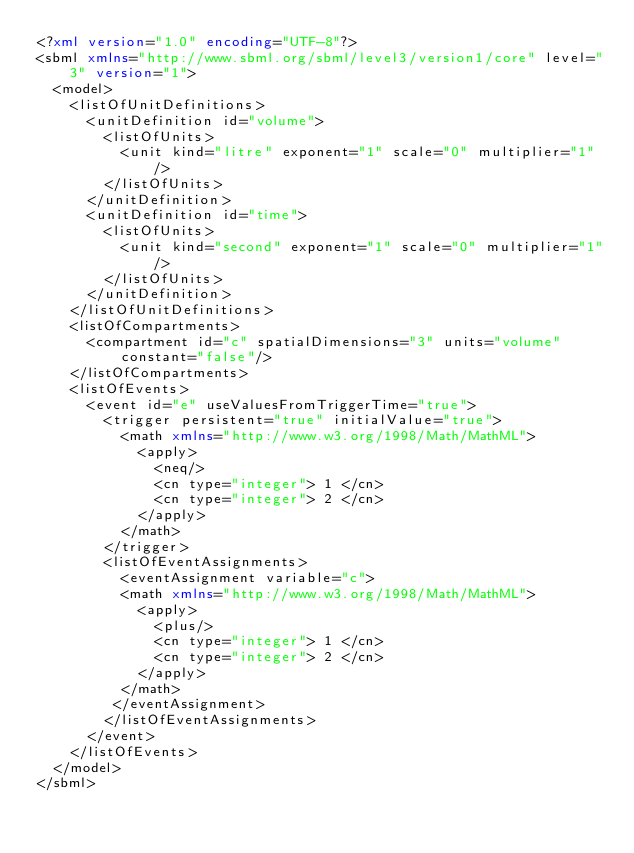<code> <loc_0><loc_0><loc_500><loc_500><_XML_><?xml version="1.0" encoding="UTF-8"?>
<sbml xmlns="http://www.sbml.org/sbml/level3/version1/core" level="3" version="1">
  <model>
    <listOfUnitDefinitions>
      <unitDefinition id="volume">
        <listOfUnits>
          <unit kind="litre" exponent="1" scale="0" multiplier="1"/>
        </listOfUnits>
      </unitDefinition>
      <unitDefinition id="time">
        <listOfUnits>
          <unit kind="second" exponent="1" scale="0" multiplier="1"/>
        </listOfUnits>
      </unitDefinition>
    </listOfUnitDefinitions>
    <listOfCompartments>
      <compartment id="c" spatialDimensions="3" units="volume" constant="false"/>
    </listOfCompartments>
    <listOfEvents>
      <event id="e" useValuesFromTriggerTime="true">
        <trigger persistent="true" initialValue="true">
          <math xmlns="http://www.w3.org/1998/Math/MathML">
            <apply>
              <neq/>
              <cn type="integer"> 1 </cn>
              <cn type="integer"> 2 </cn>
            </apply>
          </math>
        </trigger>
        <listOfEventAssignments>
          <eventAssignment variable="c">
          <math xmlns="http://www.w3.org/1998/Math/MathML">
            <apply>
              <plus/>
              <cn type="integer"> 1 </cn>
              <cn type="integer"> 2 </cn>
            </apply>
          </math>
         </eventAssignment>
        </listOfEventAssignments>
      </event>
    </listOfEvents>
  </model>
</sbml>
</code> 